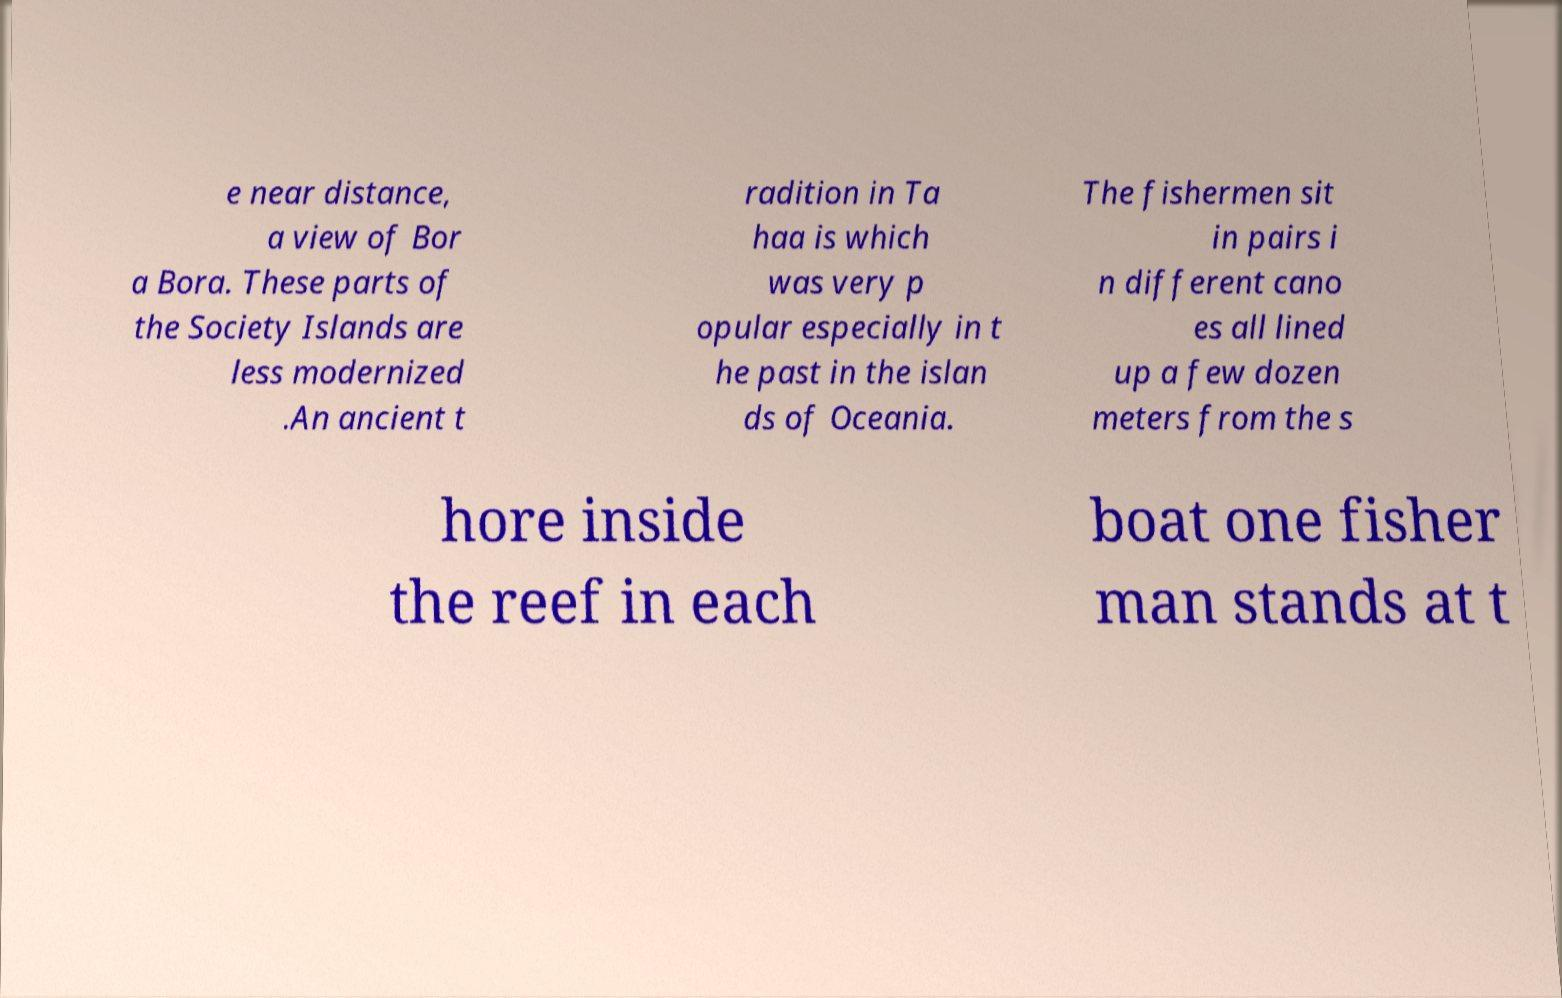There's text embedded in this image that I need extracted. Can you transcribe it verbatim? e near distance, a view of Bor a Bora. These parts of the Society Islands are less modernized .An ancient t radition in Ta haa is which was very p opular especially in t he past in the islan ds of Oceania. The fishermen sit in pairs i n different cano es all lined up a few dozen meters from the s hore inside the reef in each boat one fisher man stands at t 